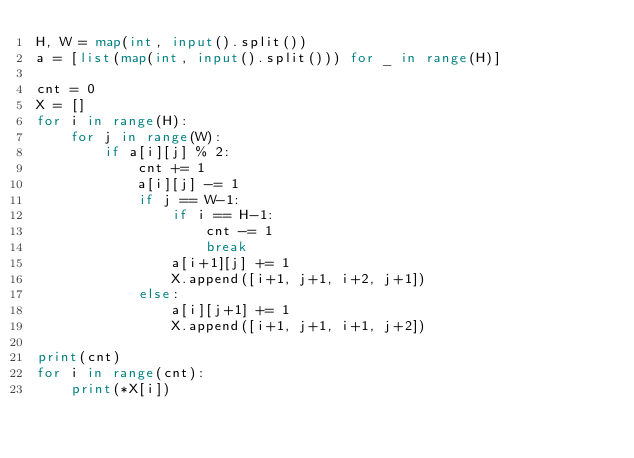<code> <loc_0><loc_0><loc_500><loc_500><_Python_>H, W = map(int, input().split())
a = [list(map(int, input().split())) for _ in range(H)]

cnt = 0
X = []
for i in range(H):
    for j in range(W):
        if a[i][j] % 2:
            cnt += 1
            a[i][j] -= 1
            if j == W-1:
                if i == H-1:
                    cnt -= 1
                    break
                a[i+1][j] += 1
                X.append([i+1, j+1, i+2, j+1])
            else:
                a[i][j+1] += 1
                X.append([i+1, j+1, i+1, j+2])

print(cnt)    
for i in range(cnt):
    print(*X[i])</code> 